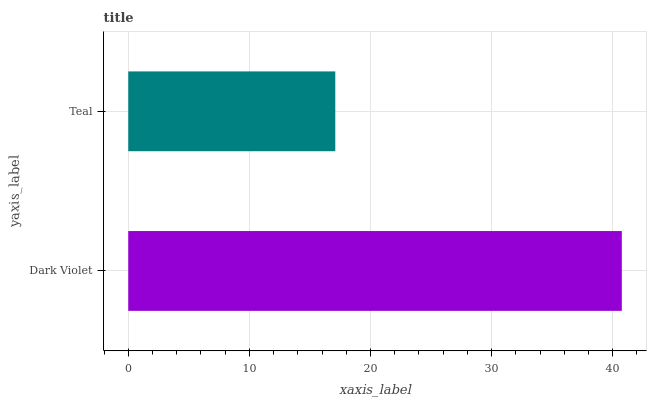Is Teal the minimum?
Answer yes or no. Yes. Is Dark Violet the maximum?
Answer yes or no. Yes. Is Teal the maximum?
Answer yes or no. No. Is Dark Violet greater than Teal?
Answer yes or no. Yes. Is Teal less than Dark Violet?
Answer yes or no. Yes. Is Teal greater than Dark Violet?
Answer yes or no. No. Is Dark Violet less than Teal?
Answer yes or no. No. Is Dark Violet the high median?
Answer yes or no. Yes. Is Teal the low median?
Answer yes or no. Yes. Is Teal the high median?
Answer yes or no. No. Is Dark Violet the low median?
Answer yes or no. No. 